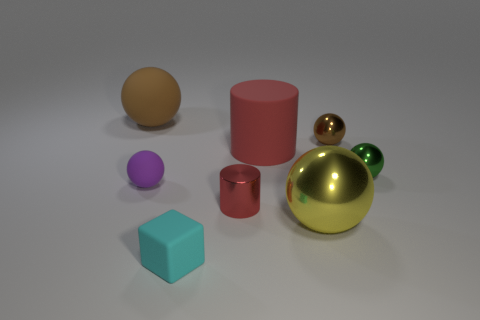How many things are behind the matte cylinder and to the right of the tiny cyan block?
Ensure brevity in your answer.  1. The tiny metal object that is on the left side of the metal object in front of the tiny red thing that is in front of the purple ball is what color?
Make the answer very short. Red. How many large balls are behind the red thing that is behind the tiny green shiny ball?
Your answer should be very brief. 1. What number of other things are there of the same shape as the tiny cyan object?
Make the answer very short. 0. How many objects are large rubber balls or big brown objects that are on the left side of the tiny cyan matte cube?
Your response must be concise. 1. Are there more cylinders that are right of the big rubber cylinder than cyan blocks that are behind the large yellow ball?
Offer a very short reply. No. The brown object in front of the large ball on the left side of the big matte thing that is on the right side of the large brown sphere is what shape?
Offer a very short reply. Sphere. What is the shape of the red object that is in front of the small sphere that is left of the cyan rubber block?
Ensure brevity in your answer.  Cylinder. Is there a green cylinder that has the same material as the small purple sphere?
Your answer should be compact. No. There is a rubber cylinder that is the same color as the metal cylinder; what is its size?
Your answer should be compact. Large. 